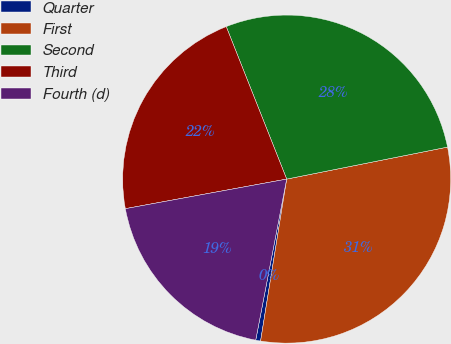<chart> <loc_0><loc_0><loc_500><loc_500><pie_chart><fcel>Quarter<fcel>First<fcel>Second<fcel>Third<fcel>Fourth (d)<nl><fcel>0.48%<fcel>30.67%<fcel>27.88%<fcel>21.88%<fcel>19.09%<nl></chart> 